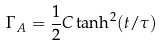<formula> <loc_0><loc_0><loc_500><loc_500>\Gamma _ { A } = \frac { 1 } { 2 } C \tanh ^ { 2 } ( t / \tau )</formula> 